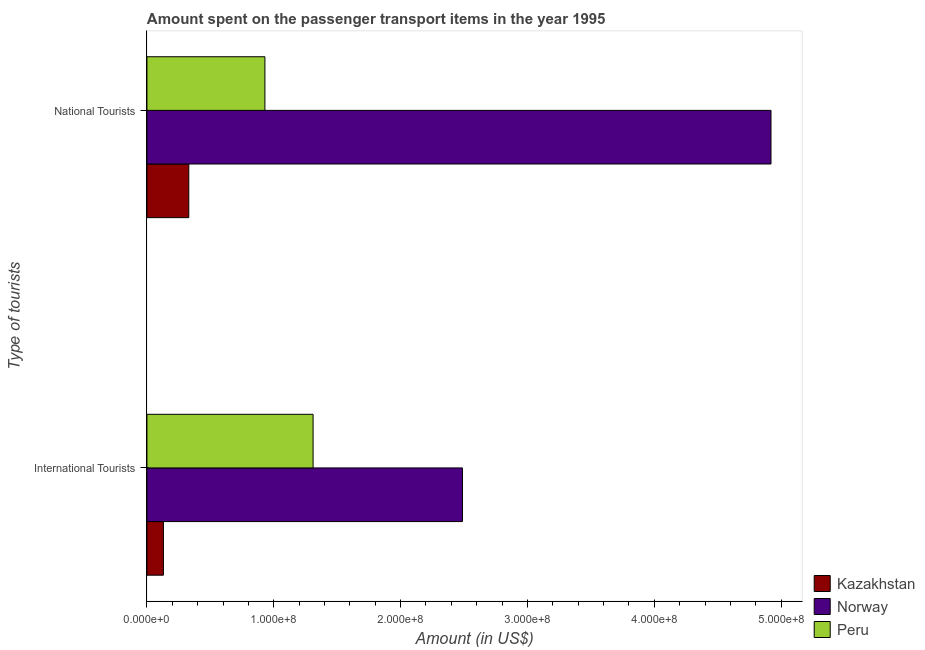How many different coloured bars are there?
Offer a terse response. 3. Are the number of bars per tick equal to the number of legend labels?
Your answer should be compact. Yes. Are the number of bars on each tick of the Y-axis equal?
Your response must be concise. Yes. How many bars are there on the 2nd tick from the bottom?
Ensure brevity in your answer.  3. What is the label of the 2nd group of bars from the top?
Keep it short and to the point. International Tourists. What is the amount spent on transport items of international tourists in Kazakhstan?
Give a very brief answer. 1.30e+07. Across all countries, what is the maximum amount spent on transport items of national tourists?
Provide a short and direct response. 4.92e+08. Across all countries, what is the minimum amount spent on transport items of national tourists?
Keep it short and to the point. 3.30e+07. In which country was the amount spent on transport items of international tourists maximum?
Make the answer very short. Norway. In which country was the amount spent on transport items of international tourists minimum?
Your answer should be very brief. Kazakhstan. What is the total amount spent on transport items of international tourists in the graph?
Offer a very short reply. 3.93e+08. What is the difference between the amount spent on transport items of national tourists in Kazakhstan and that in Peru?
Your answer should be very brief. -6.00e+07. What is the difference between the amount spent on transport items of national tourists in Norway and the amount spent on transport items of international tourists in Kazakhstan?
Ensure brevity in your answer.  4.79e+08. What is the average amount spent on transport items of international tourists per country?
Ensure brevity in your answer.  1.31e+08. What is the difference between the amount spent on transport items of international tourists and amount spent on transport items of national tourists in Peru?
Keep it short and to the point. 3.80e+07. In how many countries, is the amount spent on transport items of international tourists greater than 480000000 US$?
Give a very brief answer. 0. What is the ratio of the amount spent on transport items of national tourists in Norway to that in Peru?
Offer a terse response. 5.29. Is the amount spent on transport items of national tourists in Norway less than that in Kazakhstan?
Your answer should be very brief. No. In how many countries, is the amount spent on transport items of international tourists greater than the average amount spent on transport items of international tourists taken over all countries?
Ensure brevity in your answer.  2. How many countries are there in the graph?
Give a very brief answer. 3. Are the values on the major ticks of X-axis written in scientific E-notation?
Ensure brevity in your answer.  Yes. Does the graph contain grids?
Provide a succinct answer. No. How are the legend labels stacked?
Ensure brevity in your answer.  Vertical. What is the title of the graph?
Your answer should be compact. Amount spent on the passenger transport items in the year 1995. What is the label or title of the Y-axis?
Offer a very short reply. Type of tourists. What is the Amount (in US$) in Kazakhstan in International Tourists?
Make the answer very short. 1.30e+07. What is the Amount (in US$) in Norway in International Tourists?
Keep it short and to the point. 2.49e+08. What is the Amount (in US$) of Peru in International Tourists?
Your answer should be compact. 1.31e+08. What is the Amount (in US$) in Kazakhstan in National Tourists?
Your answer should be compact. 3.30e+07. What is the Amount (in US$) of Norway in National Tourists?
Provide a short and direct response. 4.92e+08. What is the Amount (in US$) in Peru in National Tourists?
Your answer should be compact. 9.30e+07. Across all Type of tourists, what is the maximum Amount (in US$) in Kazakhstan?
Provide a short and direct response. 3.30e+07. Across all Type of tourists, what is the maximum Amount (in US$) in Norway?
Ensure brevity in your answer.  4.92e+08. Across all Type of tourists, what is the maximum Amount (in US$) in Peru?
Ensure brevity in your answer.  1.31e+08. Across all Type of tourists, what is the minimum Amount (in US$) in Kazakhstan?
Keep it short and to the point. 1.30e+07. Across all Type of tourists, what is the minimum Amount (in US$) of Norway?
Make the answer very short. 2.49e+08. Across all Type of tourists, what is the minimum Amount (in US$) in Peru?
Your response must be concise. 9.30e+07. What is the total Amount (in US$) of Kazakhstan in the graph?
Your response must be concise. 4.60e+07. What is the total Amount (in US$) of Norway in the graph?
Provide a succinct answer. 7.41e+08. What is the total Amount (in US$) in Peru in the graph?
Your answer should be very brief. 2.24e+08. What is the difference between the Amount (in US$) of Kazakhstan in International Tourists and that in National Tourists?
Your answer should be very brief. -2.00e+07. What is the difference between the Amount (in US$) in Norway in International Tourists and that in National Tourists?
Your answer should be compact. -2.43e+08. What is the difference between the Amount (in US$) in Peru in International Tourists and that in National Tourists?
Provide a succinct answer. 3.80e+07. What is the difference between the Amount (in US$) in Kazakhstan in International Tourists and the Amount (in US$) in Norway in National Tourists?
Give a very brief answer. -4.79e+08. What is the difference between the Amount (in US$) in Kazakhstan in International Tourists and the Amount (in US$) in Peru in National Tourists?
Your answer should be very brief. -8.00e+07. What is the difference between the Amount (in US$) in Norway in International Tourists and the Amount (in US$) in Peru in National Tourists?
Your answer should be compact. 1.56e+08. What is the average Amount (in US$) in Kazakhstan per Type of tourists?
Give a very brief answer. 2.30e+07. What is the average Amount (in US$) of Norway per Type of tourists?
Provide a succinct answer. 3.70e+08. What is the average Amount (in US$) of Peru per Type of tourists?
Give a very brief answer. 1.12e+08. What is the difference between the Amount (in US$) in Kazakhstan and Amount (in US$) in Norway in International Tourists?
Keep it short and to the point. -2.36e+08. What is the difference between the Amount (in US$) of Kazakhstan and Amount (in US$) of Peru in International Tourists?
Offer a very short reply. -1.18e+08. What is the difference between the Amount (in US$) in Norway and Amount (in US$) in Peru in International Tourists?
Offer a very short reply. 1.18e+08. What is the difference between the Amount (in US$) of Kazakhstan and Amount (in US$) of Norway in National Tourists?
Ensure brevity in your answer.  -4.59e+08. What is the difference between the Amount (in US$) in Kazakhstan and Amount (in US$) in Peru in National Tourists?
Offer a terse response. -6.00e+07. What is the difference between the Amount (in US$) of Norway and Amount (in US$) of Peru in National Tourists?
Keep it short and to the point. 3.99e+08. What is the ratio of the Amount (in US$) in Kazakhstan in International Tourists to that in National Tourists?
Keep it short and to the point. 0.39. What is the ratio of the Amount (in US$) of Norway in International Tourists to that in National Tourists?
Make the answer very short. 0.51. What is the ratio of the Amount (in US$) of Peru in International Tourists to that in National Tourists?
Give a very brief answer. 1.41. What is the difference between the highest and the second highest Amount (in US$) in Kazakhstan?
Give a very brief answer. 2.00e+07. What is the difference between the highest and the second highest Amount (in US$) of Norway?
Your answer should be compact. 2.43e+08. What is the difference between the highest and the second highest Amount (in US$) in Peru?
Offer a terse response. 3.80e+07. What is the difference between the highest and the lowest Amount (in US$) in Norway?
Offer a very short reply. 2.43e+08. What is the difference between the highest and the lowest Amount (in US$) in Peru?
Your answer should be compact. 3.80e+07. 